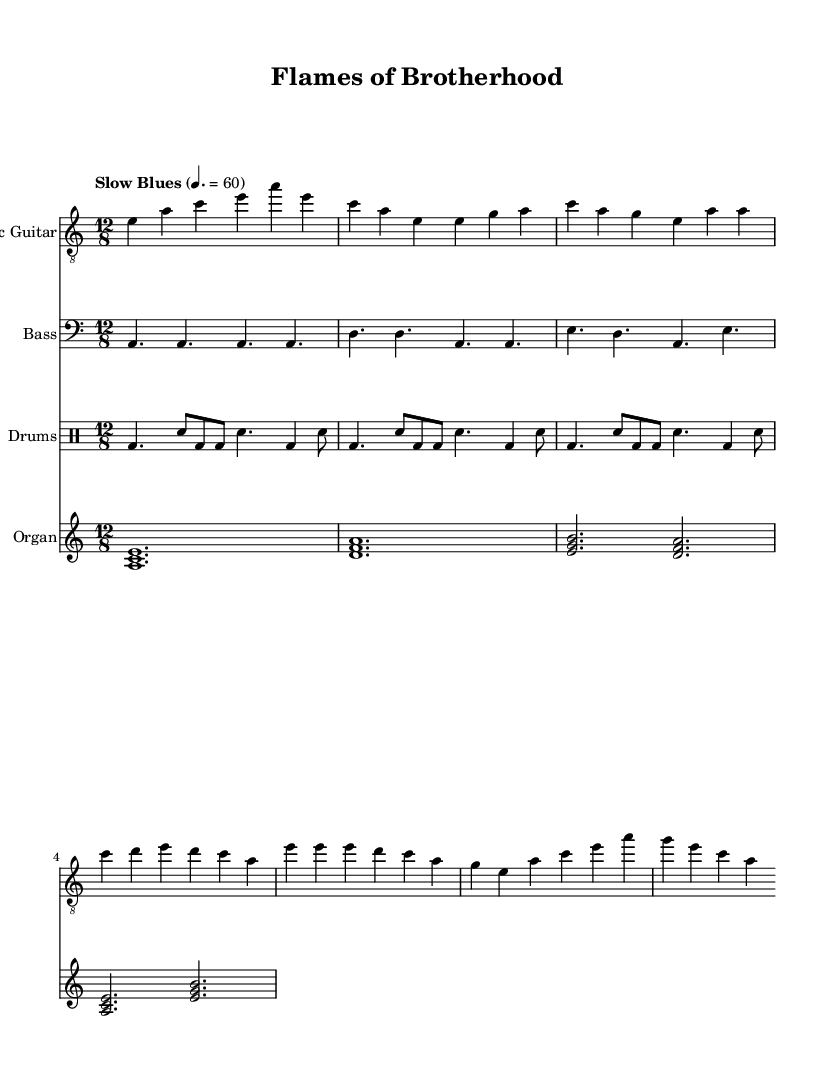What is the time signature of this music? The time signature indicates how many beats are in each measure. In this case, the time signature indicates 12 beats per measure.
Answer: 12/8 What key is the music composed in? The key signature shows that the music is in A minor, identified by the absence of sharps or flats.
Answer: A minor What tempo is indicated for this piece? The tempo is indicated as "Slow Blues," which tells the musician to play at a moderate speed of 60 beats per minute.
Answer: Slow Blues How many measures are in the electric guitar part? Counting visually, the electric guitar part has a total of 6 measures as indicated by the layout of the music.
Answer: 6 What chord is played in the first measure of the organ part? The organ part opens with an A minor chord, which is represented by the notes A, C, and E played together.
Answer: A minor What instrument accompanies the bass guitar in this composition? The bass guitar is accompanied by both the electric guitar and the drums, which work together to create the rhythmic foundation of the piece.
Answer: Electric guitar and drums What is the primary theme expressed in the music? The overall theme can be interpreted as exploring the camaraderie and brotherhood among firefighters through soulful electric blues.
Answer: Camaraderie and brotherhood 